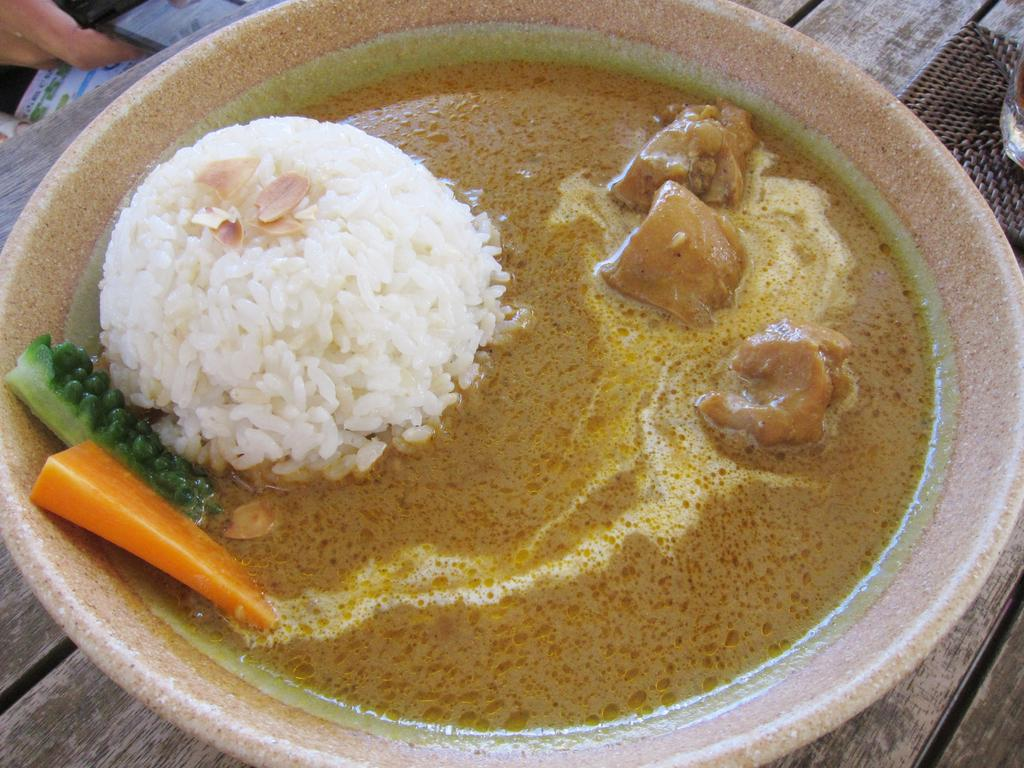What is located at the bottom of the image? There is a table at the bottom of the image. What is on the table? There is a plate on the table. What is in the plate? There is food in the plate. Can you describe the person visible in the image? A person is visible behind the table. What is the person holding? The person is holding something. How many birds are sitting on the person's head in the image? There are no birds present in the image, and the person's head is not visible. Is there a wound visible on the person's arm in the image? There is no mention of a wound in the provided facts, and the person's arm is not visible in the image. 